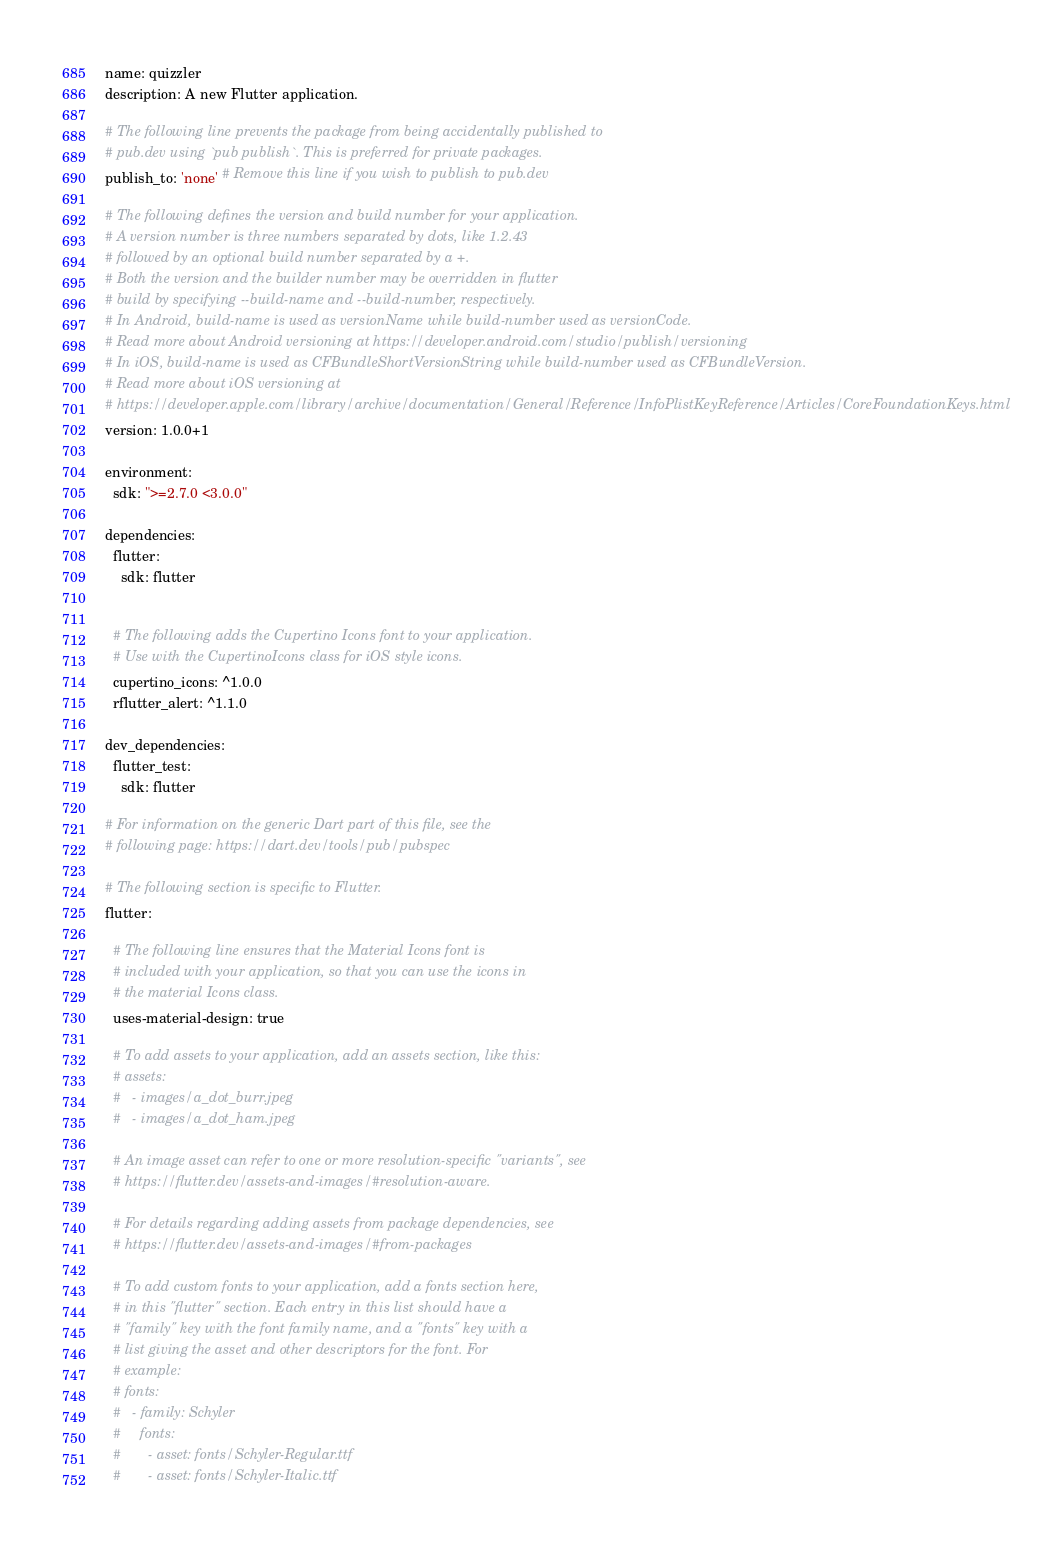<code> <loc_0><loc_0><loc_500><loc_500><_YAML_>name: quizzler
description: A new Flutter application.

# The following line prevents the package from being accidentally published to
# pub.dev using `pub publish`. This is preferred for private packages.
publish_to: 'none' # Remove this line if you wish to publish to pub.dev

# The following defines the version and build number for your application.
# A version number is three numbers separated by dots, like 1.2.43
# followed by an optional build number separated by a +.
# Both the version and the builder number may be overridden in flutter
# build by specifying --build-name and --build-number, respectively.
# In Android, build-name is used as versionName while build-number used as versionCode.
# Read more about Android versioning at https://developer.android.com/studio/publish/versioning
# In iOS, build-name is used as CFBundleShortVersionString while build-number used as CFBundleVersion.
# Read more about iOS versioning at
# https://developer.apple.com/library/archive/documentation/General/Reference/InfoPlistKeyReference/Articles/CoreFoundationKeys.html
version: 1.0.0+1

environment:
  sdk: ">=2.7.0 <3.0.0"

dependencies:
  flutter:
    sdk: flutter


  # The following adds the Cupertino Icons font to your application.
  # Use with the CupertinoIcons class for iOS style icons.
  cupertino_icons: ^1.0.0
  rflutter_alert: ^1.1.0

dev_dependencies:
  flutter_test:
    sdk: flutter

# For information on the generic Dart part of this file, see the
# following page: https://dart.dev/tools/pub/pubspec

# The following section is specific to Flutter.
flutter:

  # The following line ensures that the Material Icons font is
  # included with your application, so that you can use the icons in
  # the material Icons class.
  uses-material-design: true

  # To add assets to your application, add an assets section, like this:
  # assets:
  #   - images/a_dot_burr.jpeg
  #   - images/a_dot_ham.jpeg

  # An image asset can refer to one or more resolution-specific "variants", see
  # https://flutter.dev/assets-and-images/#resolution-aware.

  # For details regarding adding assets from package dependencies, see
  # https://flutter.dev/assets-and-images/#from-packages

  # To add custom fonts to your application, add a fonts section here,
  # in this "flutter" section. Each entry in this list should have a
  # "family" key with the font family name, and a "fonts" key with a
  # list giving the asset and other descriptors for the font. For
  # example:
  # fonts:
  #   - family: Schyler
  #     fonts:
  #       - asset: fonts/Schyler-Regular.ttf
  #       - asset: fonts/Schyler-Italic.ttf</code> 